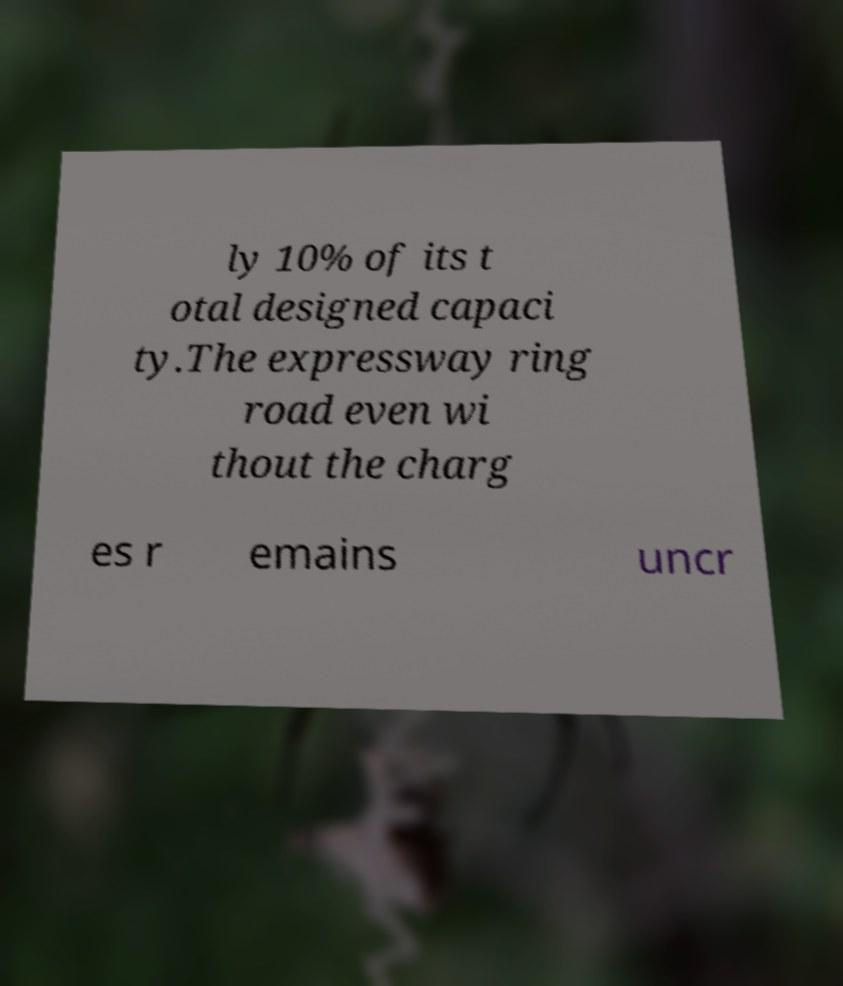Can you read and provide the text displayed in the image?This photo seems to have some interesting text. Can you extract and type it out for me? ly 10% of its t otal designed capaci ty.The expressway ring road even wi thout the charg es r emains uncr 